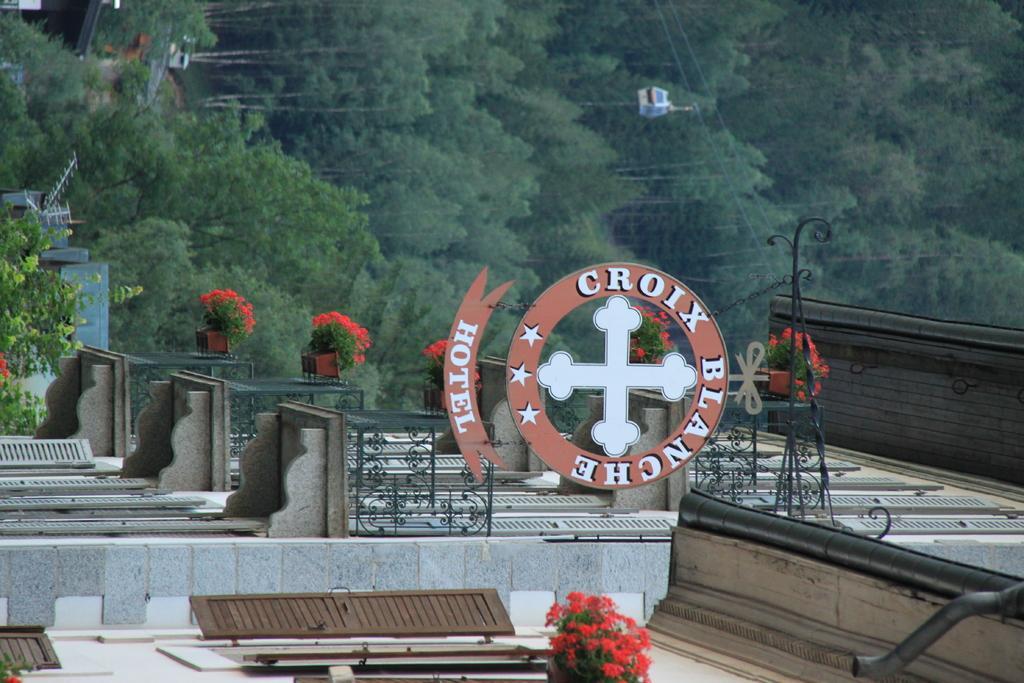How would you summarize this image in a sentence or two? In this image we can see building and a board is attached to the building. Top of the image trees are there and wires are present. 